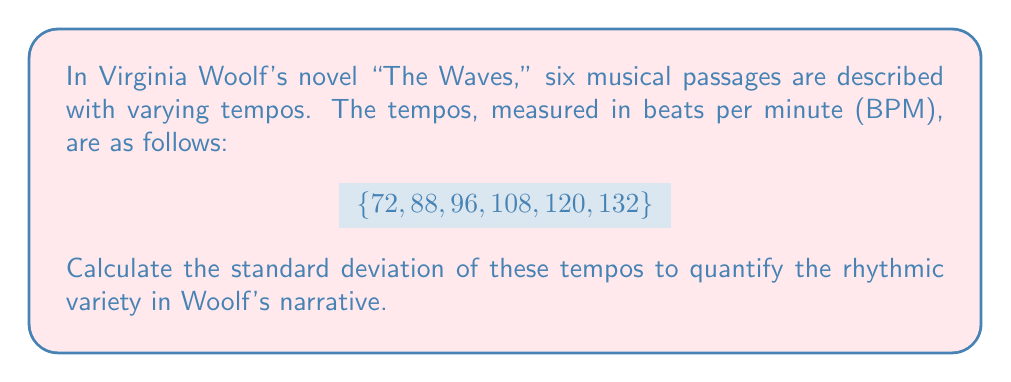Can you answer this question? To calculate the standard deviation, we'll follow these steps:

1. Calculate the mean (average) tempo:
   $$\bar{x} = \frac{72 + 88 + 96 + 108 + 120 + 132}{6} = 102.67$$

2. Calculate the squared differences from the mean:
   $$(72 - 102.67)^2 = (-30.67)^2 = 940.65$$
   $$(88 - 102.67)^2 = (-14.67)^2 = 215.21$$
   $$(96 - 102.67)^2 = (-6.67)^2 = 44.49$$
   $$(108 - 102.67)^2 = (5.33)^2 = 28.41$$
   $$(120 - 102.67)^2 = (17.33)^2 = 300.33$$
   $$(132 - 102.67)^2 = (29.33)^2 = 860.25$$

3. Calculate the average of these squared differences:
   $$\frac{940.65 + 215.21 + 44.49 + 28.41 + 300.33 + 860.25}{6} = 398.22$$

4. Take the square root of this average to get the standard deviation:
   $$\sigma = \sqrt{398.22} \approx 19.96$$

Therefore, the standard deviation of the tempos is approximately 19.96 BPM.
Answer: 19.96 BPM 